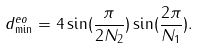<formula> <loc_0><loc_0><loc_500><loc_500>d ^ { e o } _ { \min } = 4 \sin ( \frac { \pi } { 2 N _ { 2 } } ) \sin ( \frac { 2 \pi } { N _ { 1 } } ) .</formula> 